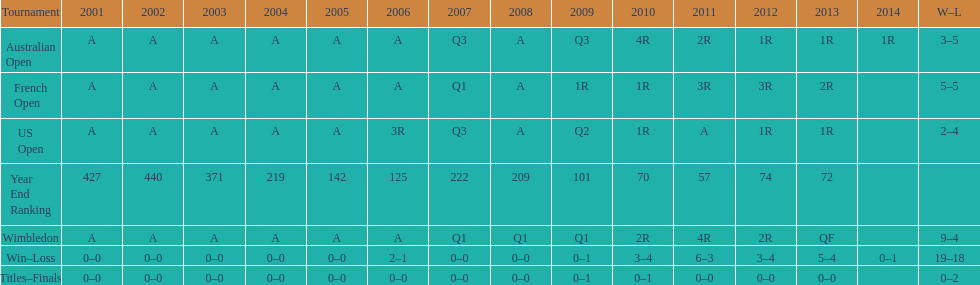What is the difference in wins between wimbledon and the us open for this player? 7. 